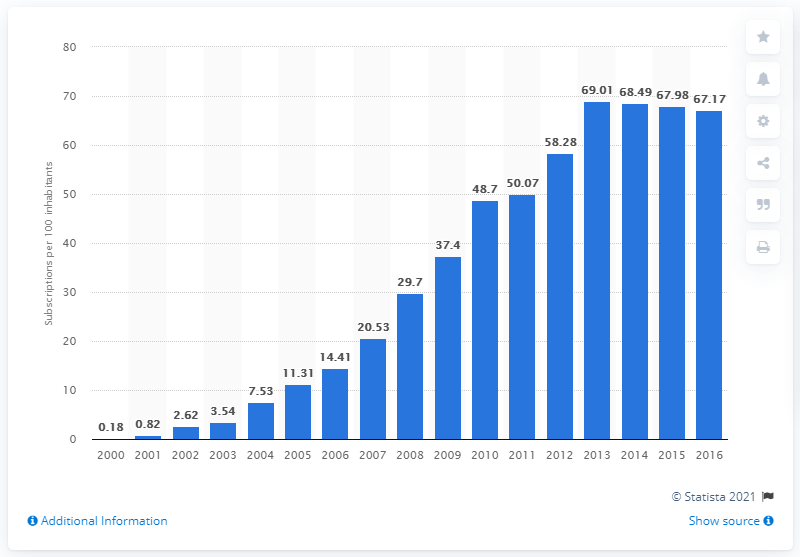Draw attention to some important aspects in this diagram. During the period of 2000 to 2016, there were approximately 67.17 mobile subscriptions registered for every 100 people in Yemen. 